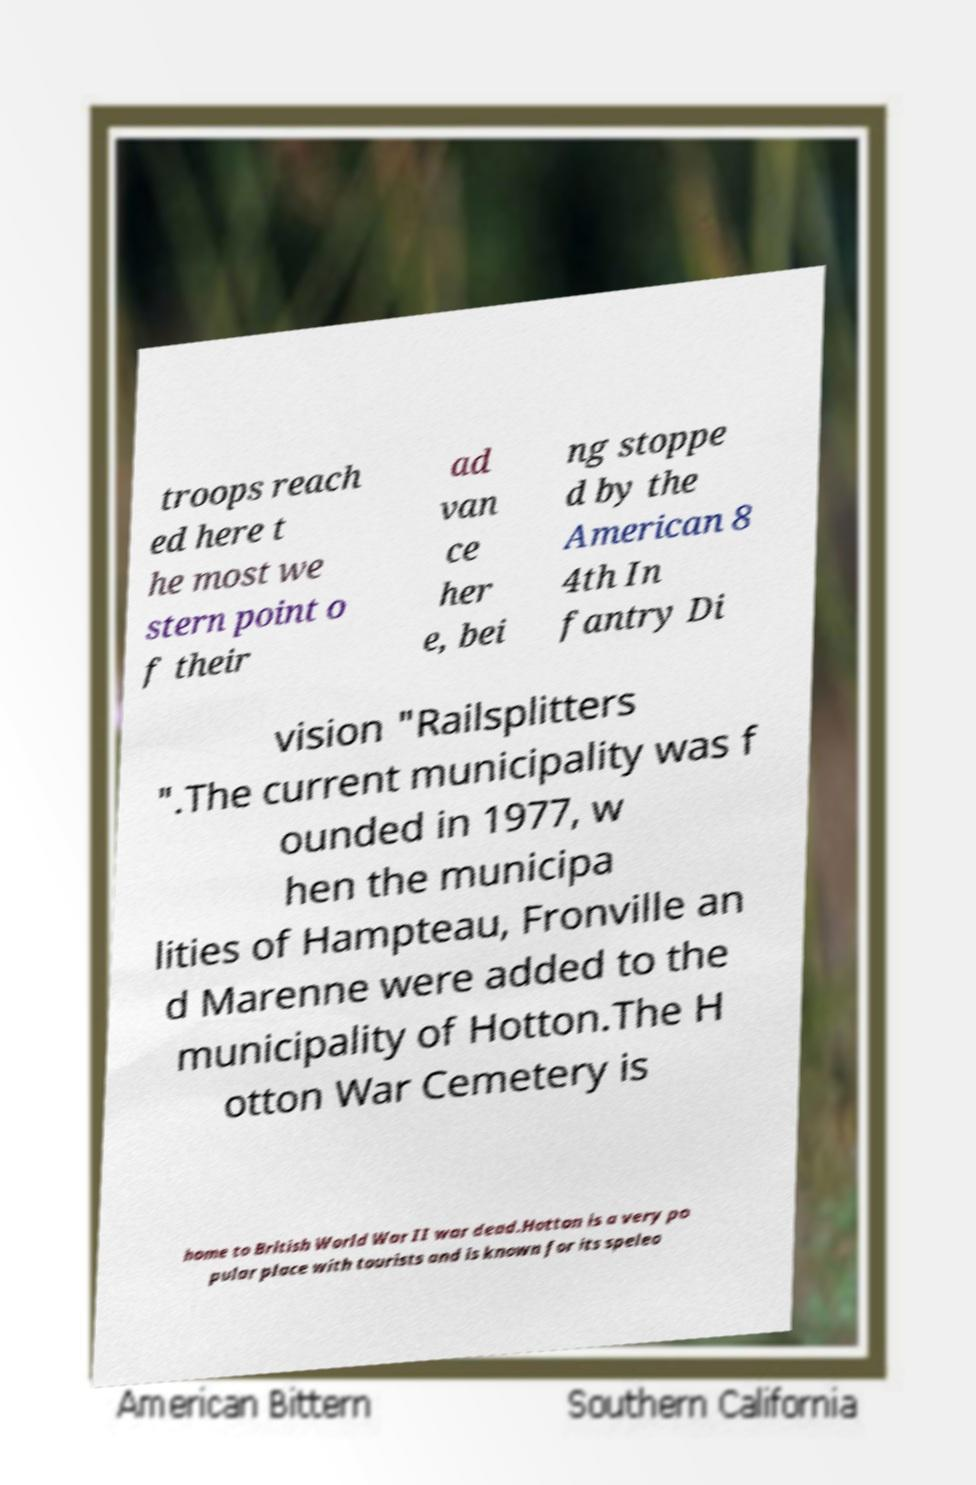Can you read and provide the text displayed in the image?This photo seems to have some interesting text. Can you extract and type it out for me? troops reach ed here t he most we stern point o f their ad van ce her e, bei ng stoppe d by the American 8 4th In fantry Di vision "Railsplitters ".The current municipality was f ounded in 1977, w hen the municipa lities of Hampteau, Fronville an d Marenne were added to the municipality of Hotton.The H otton War Cemetery is home to British World War II war dead.Hotton is a very po pular place with tourists and is known for its speleo 